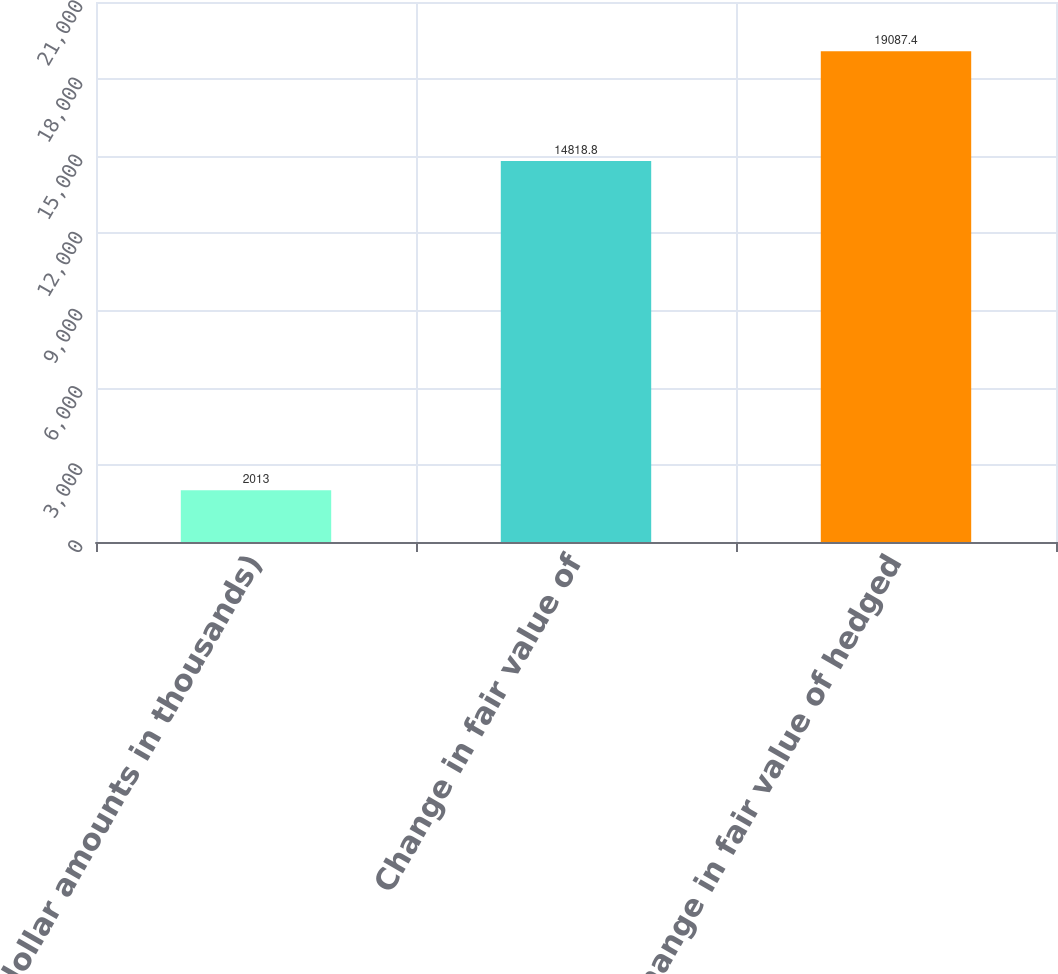Convert chart. <chart><loc_0><loc_0><loc_500><loc_500><bar_chart><fcel>(dollar amounts in thousands)<fcel>Change in fair value of<fcel>Change in fair value of hedged<nl><fcel>2013<fcel>14818.8<fcel>19087.4<nl></chart> 